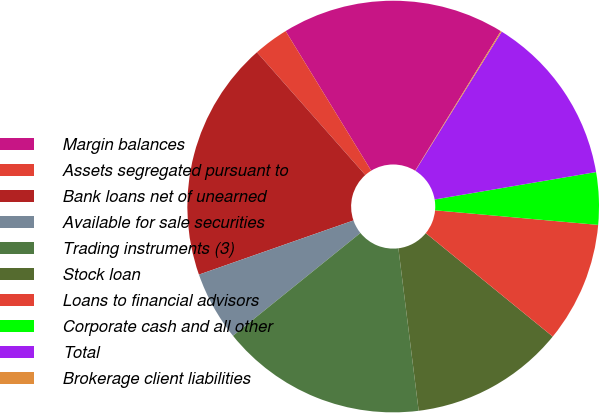<chart> <loc_0><loc_0><loc_500><loc_500><pie_chart><fcel>Margin balances<fcel>Assets segregated pursuant to<fcel>Bank loans net of unearned<fcel>Available for sale securities<fcel>Trading instruments (3)<fcel>Stock loan<fcel>Loans to financial advisors<fcel>Corporate cash and all other<fcel>Total<fcel>Brokerage client liabilities<nl><fcel>17.51%<fcel>2.76%<fcel>18.85%<fcel>5.44%<fcel>16.17%<fcel>12.14%<fcel>9.46%<fcel>4.1%<fcel>13.48%<fcel>0.08%<nl></chart> 